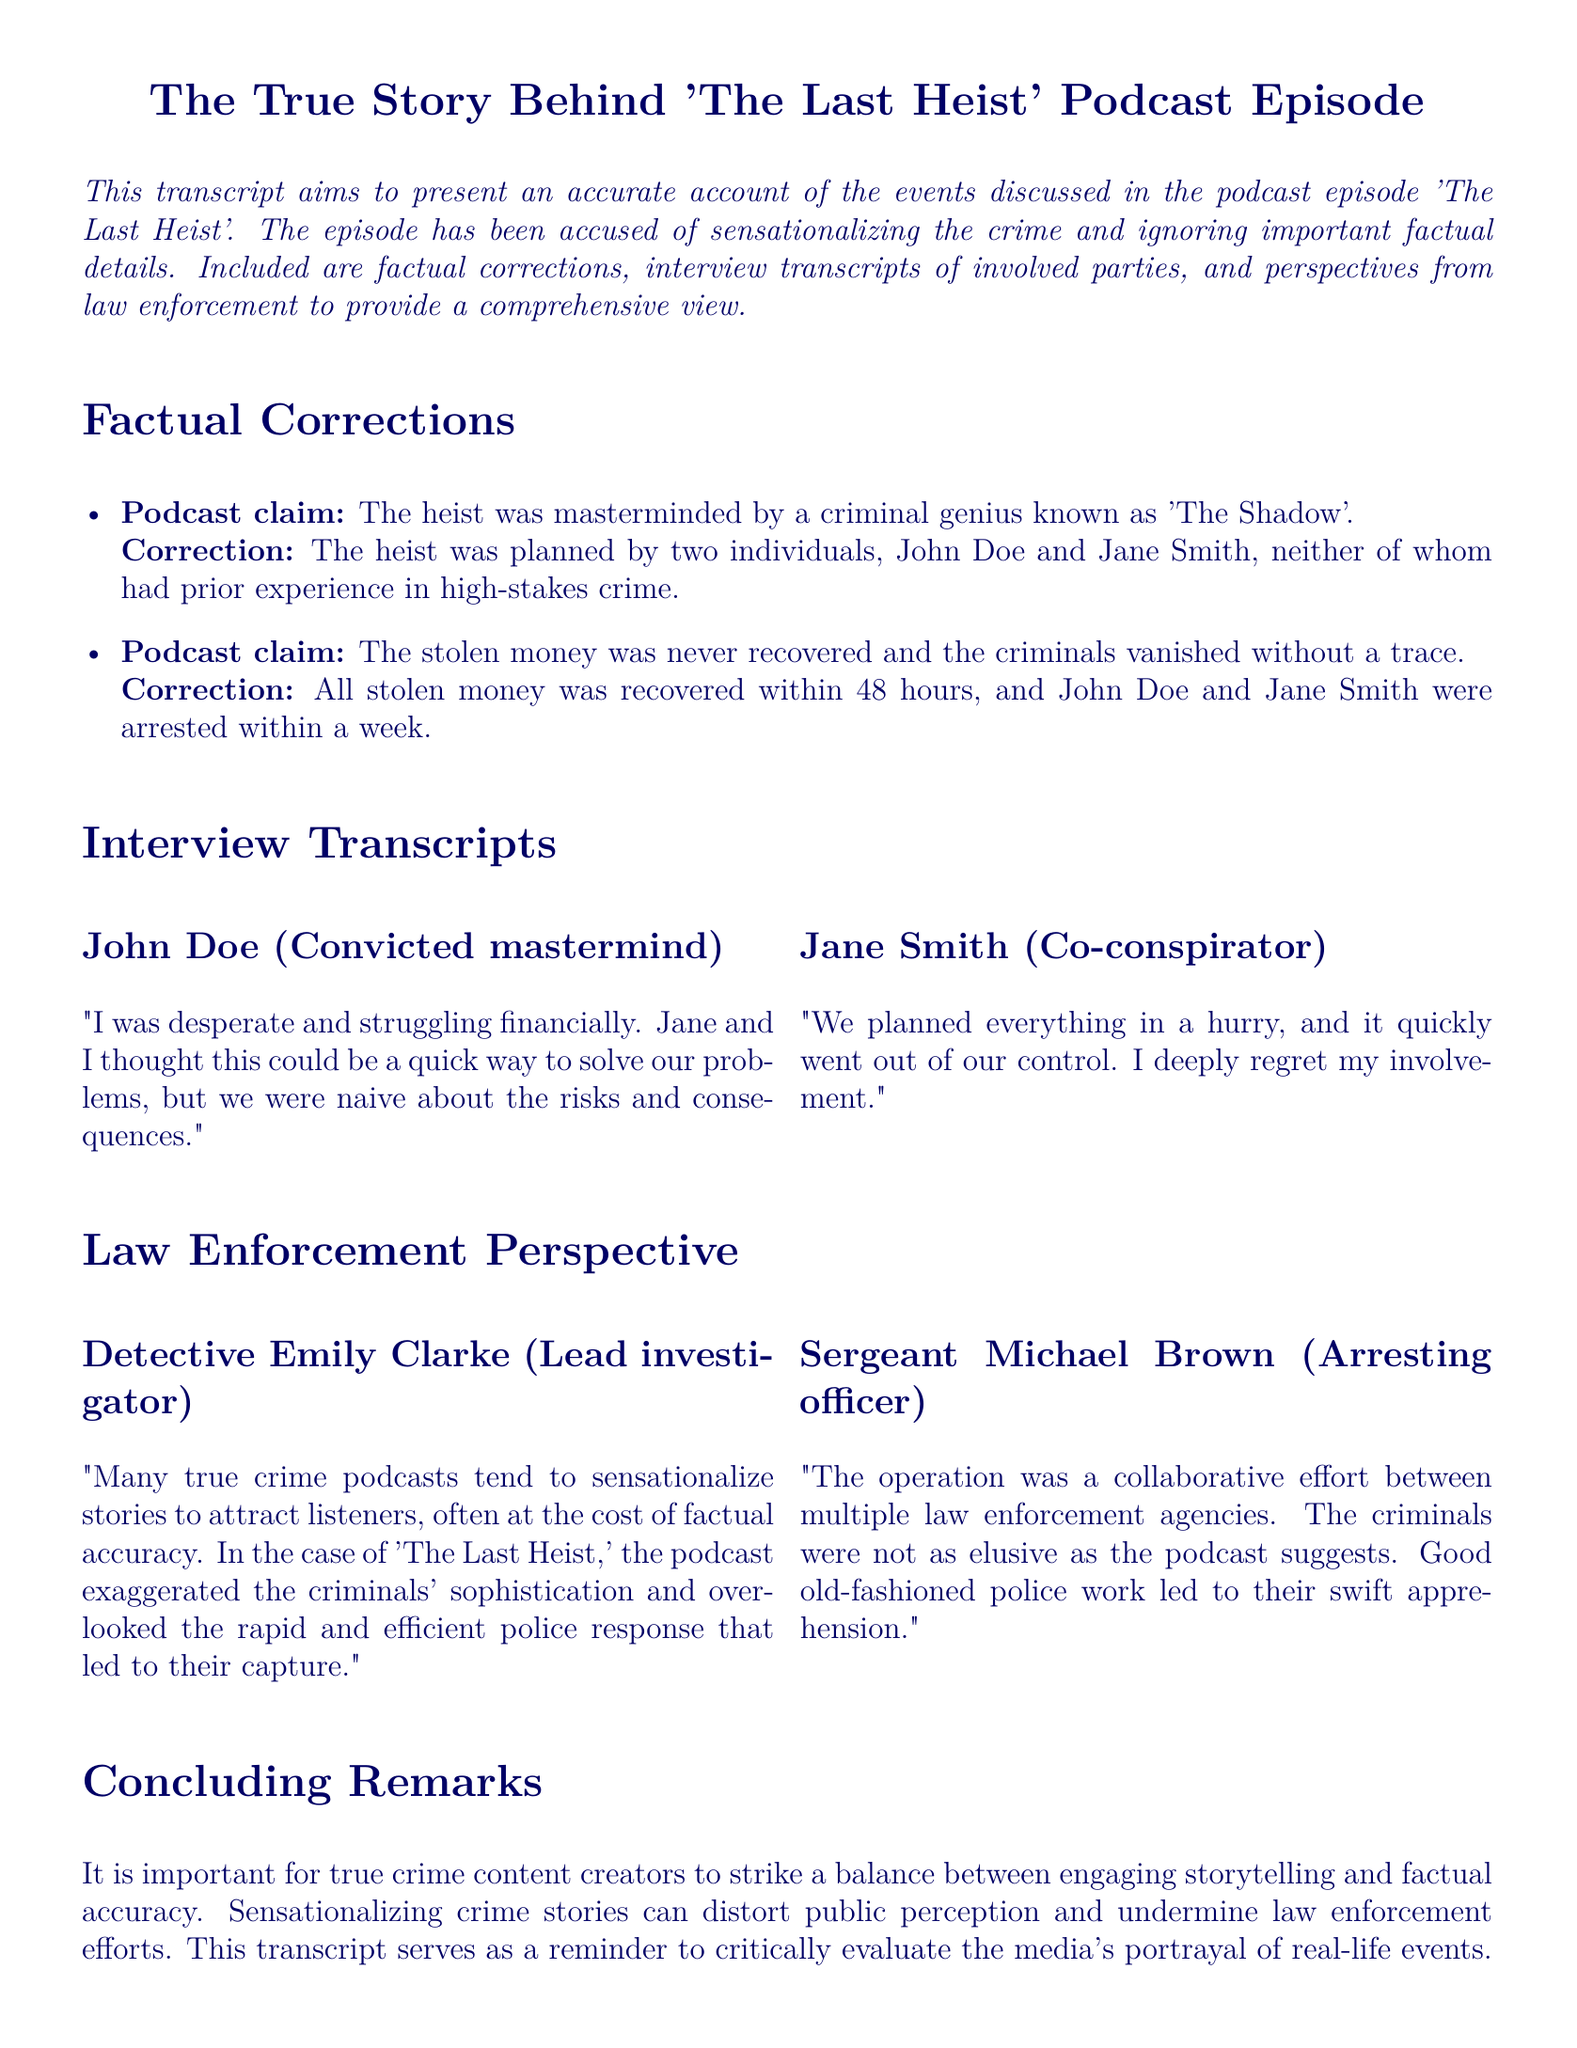What was the alias of the supposed mastermind behind the heist? The podcast claimed the heist was masterminded by a person known as 'The Shadow'.
Answer: 'The Shadow' Who were the actual planners of the heist? The heist was planned by two individuals, John Doe and Jane Smith.
Answer: John Doe and Jane Smith How long did it take to recover all the stolen money? The document states that all stolen money was recovered within a specific timeframe.
Answer: 48 hours What role did Detective Emily Clarke have in the investigation? Detective Emily Clarke is identified as the lead investigator in the case.
Answer: Lead investigator What did Jane Smith express about her involvement? Jane Smith expressed a specific sentiment regarding her participation in the crime.
Answer: She deeply regrets her involvement How did the law enforcement perceive the sophistication of the criminals? The law enforcement perspective indicates their view on the criminals' sophistication.
Answer: Exaggerated What means did the police use to capture the criminals? The response outlines the methods that led to the criminals' apprehension.
Answer: Good old-fashioned police work What is a concern mentioned about true crime podcasts? The document reflects a specific concern regarding sensationalized true crime narratives.
Answer: Distort public perception Who was the arresting officer mentioned in the document? The document identifies a specific individual who was the arresting officer.
Answer: Sergeant Michael Brown 